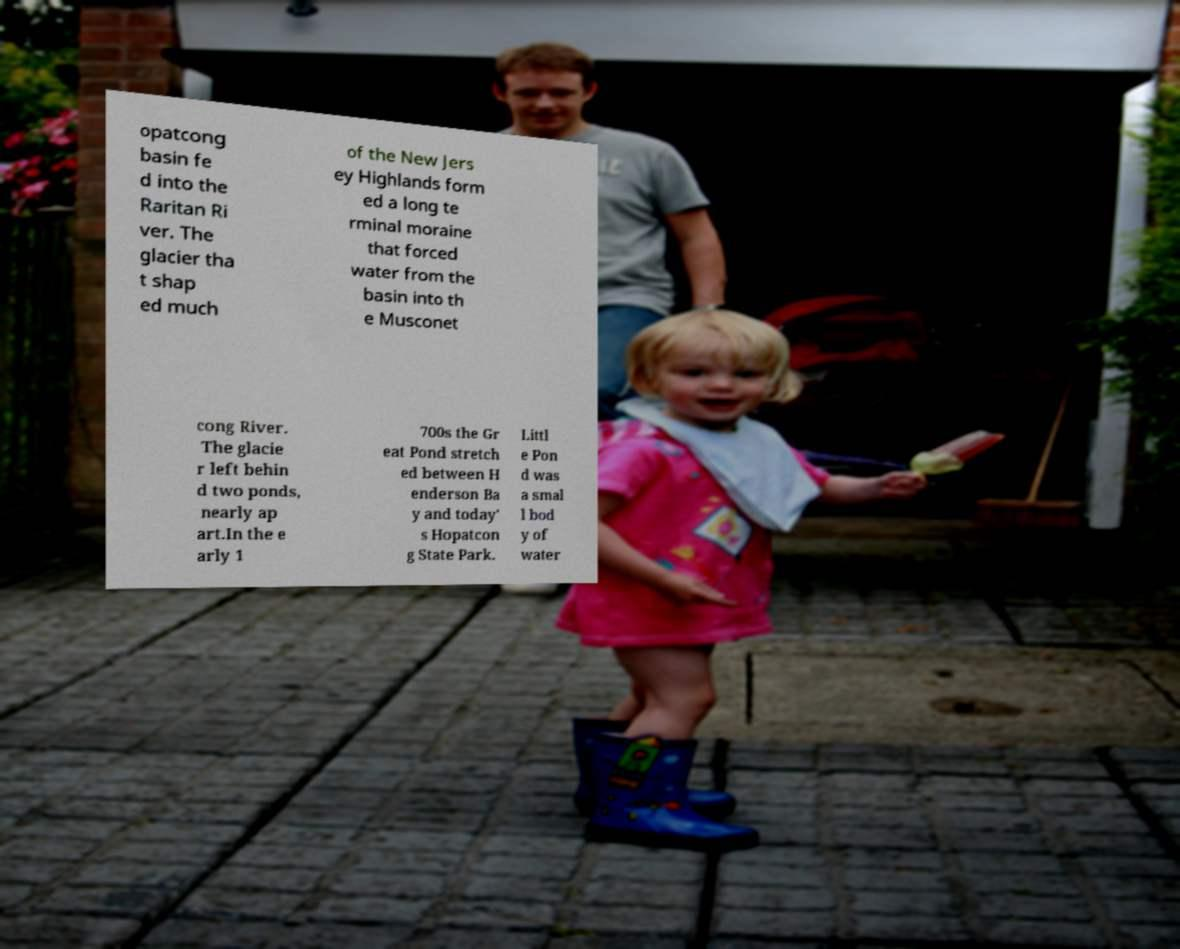I need the written content from this picture converted into text. Can you do that? opatcong basin fe d into the Raritan Ri ver. The glacier tha t shap ed much of the New Jers ey Highlands form ed a long te rminal moraine that forced water from the basin into th e Musconet cong River. The glacie r left behin d two ponds, nearly ap art.In the e arly 1 700s the Gr eat Pond stretch ed between H enderson Ba y and today' s Hopatcon g State Park. Littl e Pon d was a smal l bod y of water 